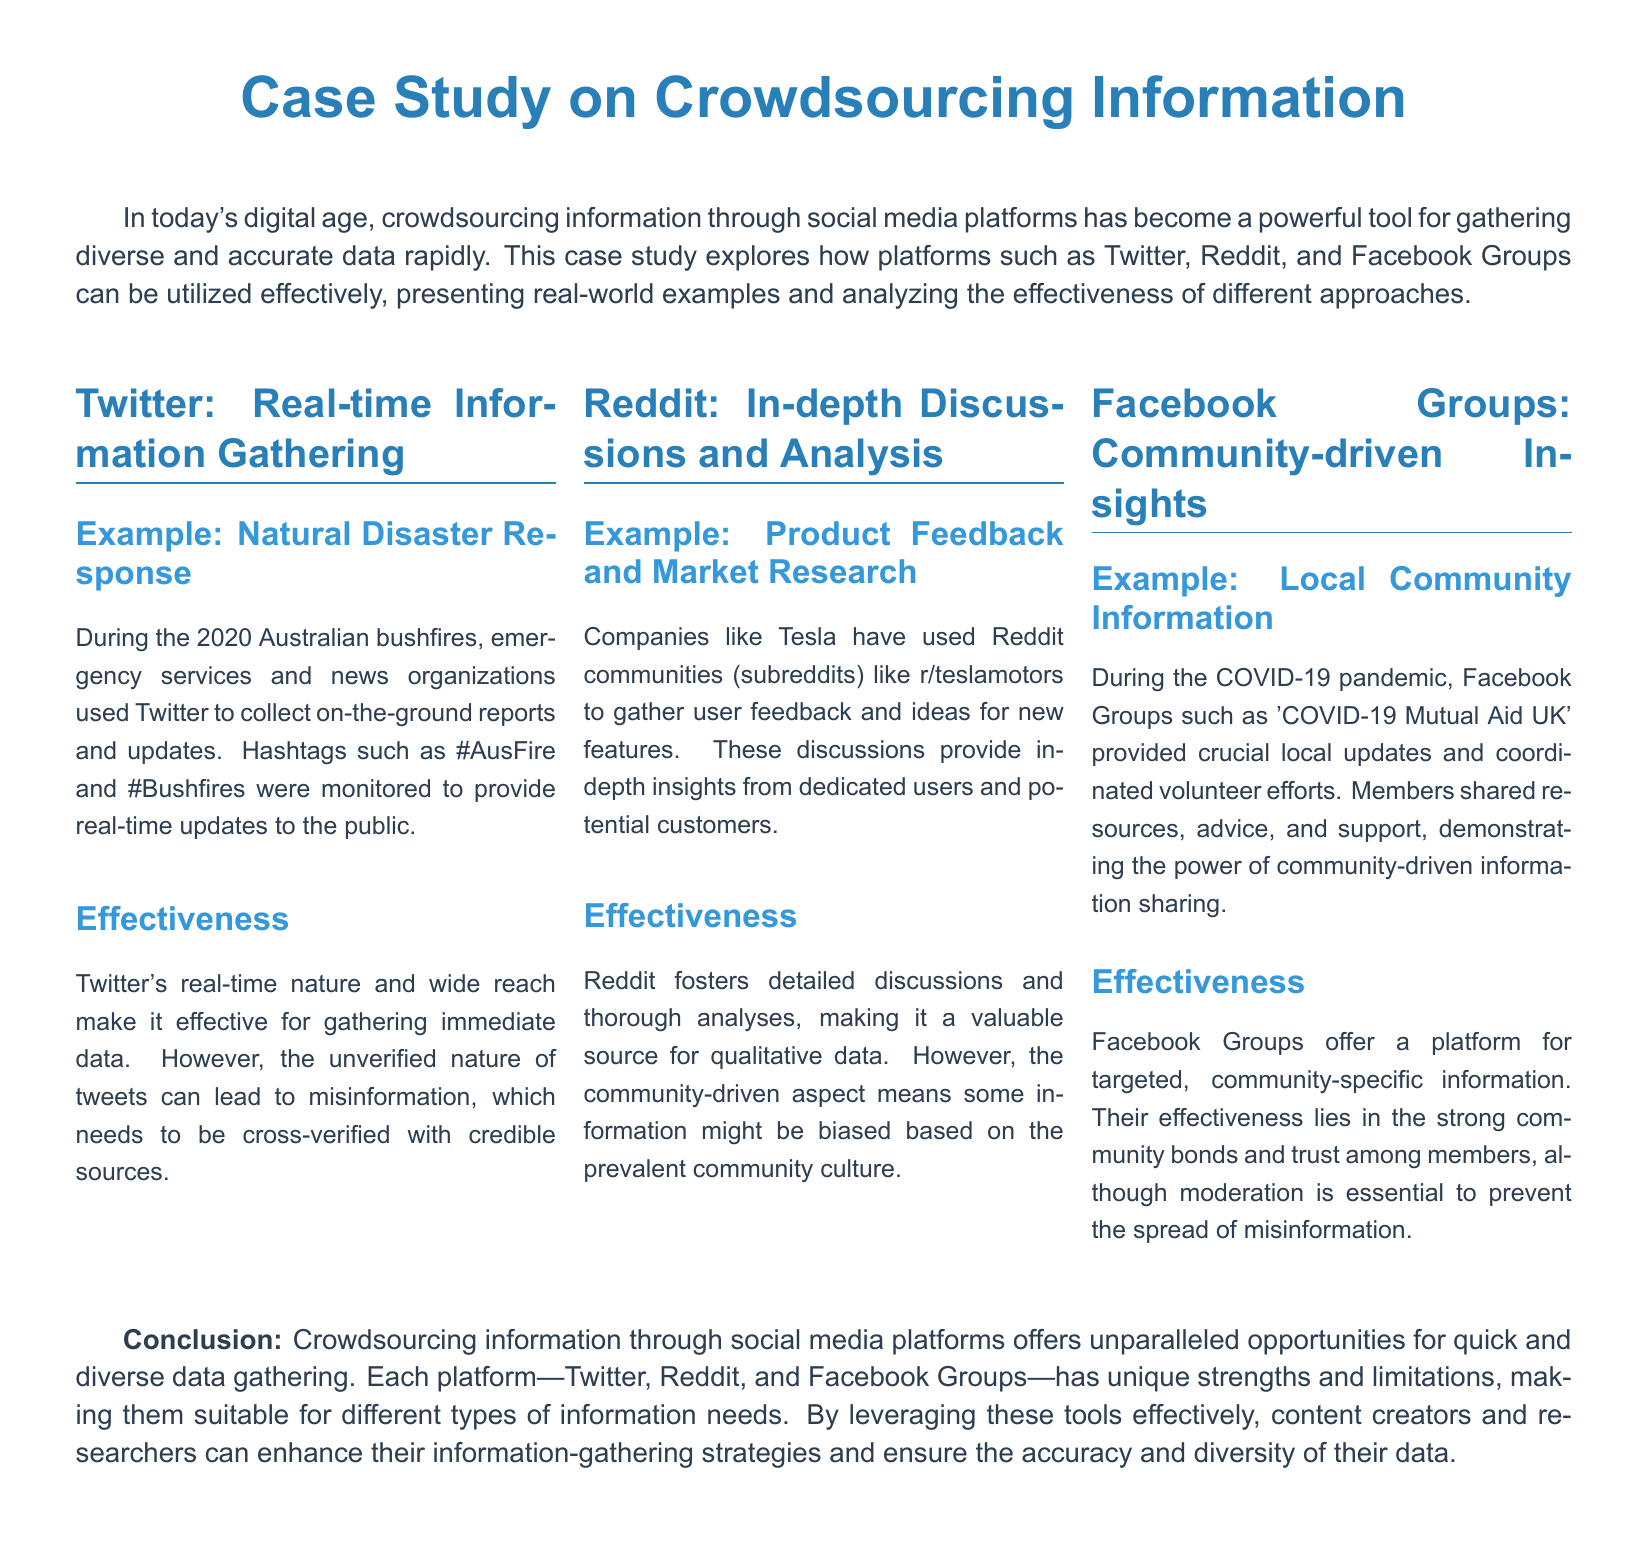What were the hashtags used during the Australian bushfires? The hashtags used were #AusFire and #Bushfires to gather on-the-ground reports and updates.
Answer: #AusFire and #Bushfires What is an example of using Reddit for market research? Tesla used the subreddit r/teslamotors to gather user feedback and ideas for new features from dedicated users.
Answer: r/teslamotors What community group provided updates during the COVID-19 pandemic? The group 'COVID-19 Mutual Aid UK' provided crucial local updates and coordinated volunteer efforts during the pandemic.
Answer: COVID-19 Mutual Aid UK Which platform is mentioned as being effective for real-time information gathering? Twitter is highlighted for its effectiveness in gathering immediate data due to its real-time nature and wide reach.
Answer: Twitter What does the conclusion suggest about crowdsourcing information through social media? The conclusion suggests that it offers unparalleled opportunities for quick and diverse data gathering, highlighting the unique strengths of each platform.
Answer: Unparalleled opportunities What aspect of Reddit could lead to biased information? The community-driven aspect of Reddit means some information might be biased based on the prevalent community culture.
Answer: Community culture How did Facebook Groups help during the COVID-19 pandemic? Facebook Groups helped by providing a platform for targeted, community-specific information and coordinating volunteer efforts.
Answer: Community-specific information What is a limitation of Twitter mentioned in the document? A limitation mentioned is the unverified nature of tweets which can lead to misinformation.
Answer: Misinformation What is the focus of the case study? The case study focuses on how leveraging social media platforms aids in gathering diverse and accurate information quickly.
Answer: Gathering diverse and accurate information 